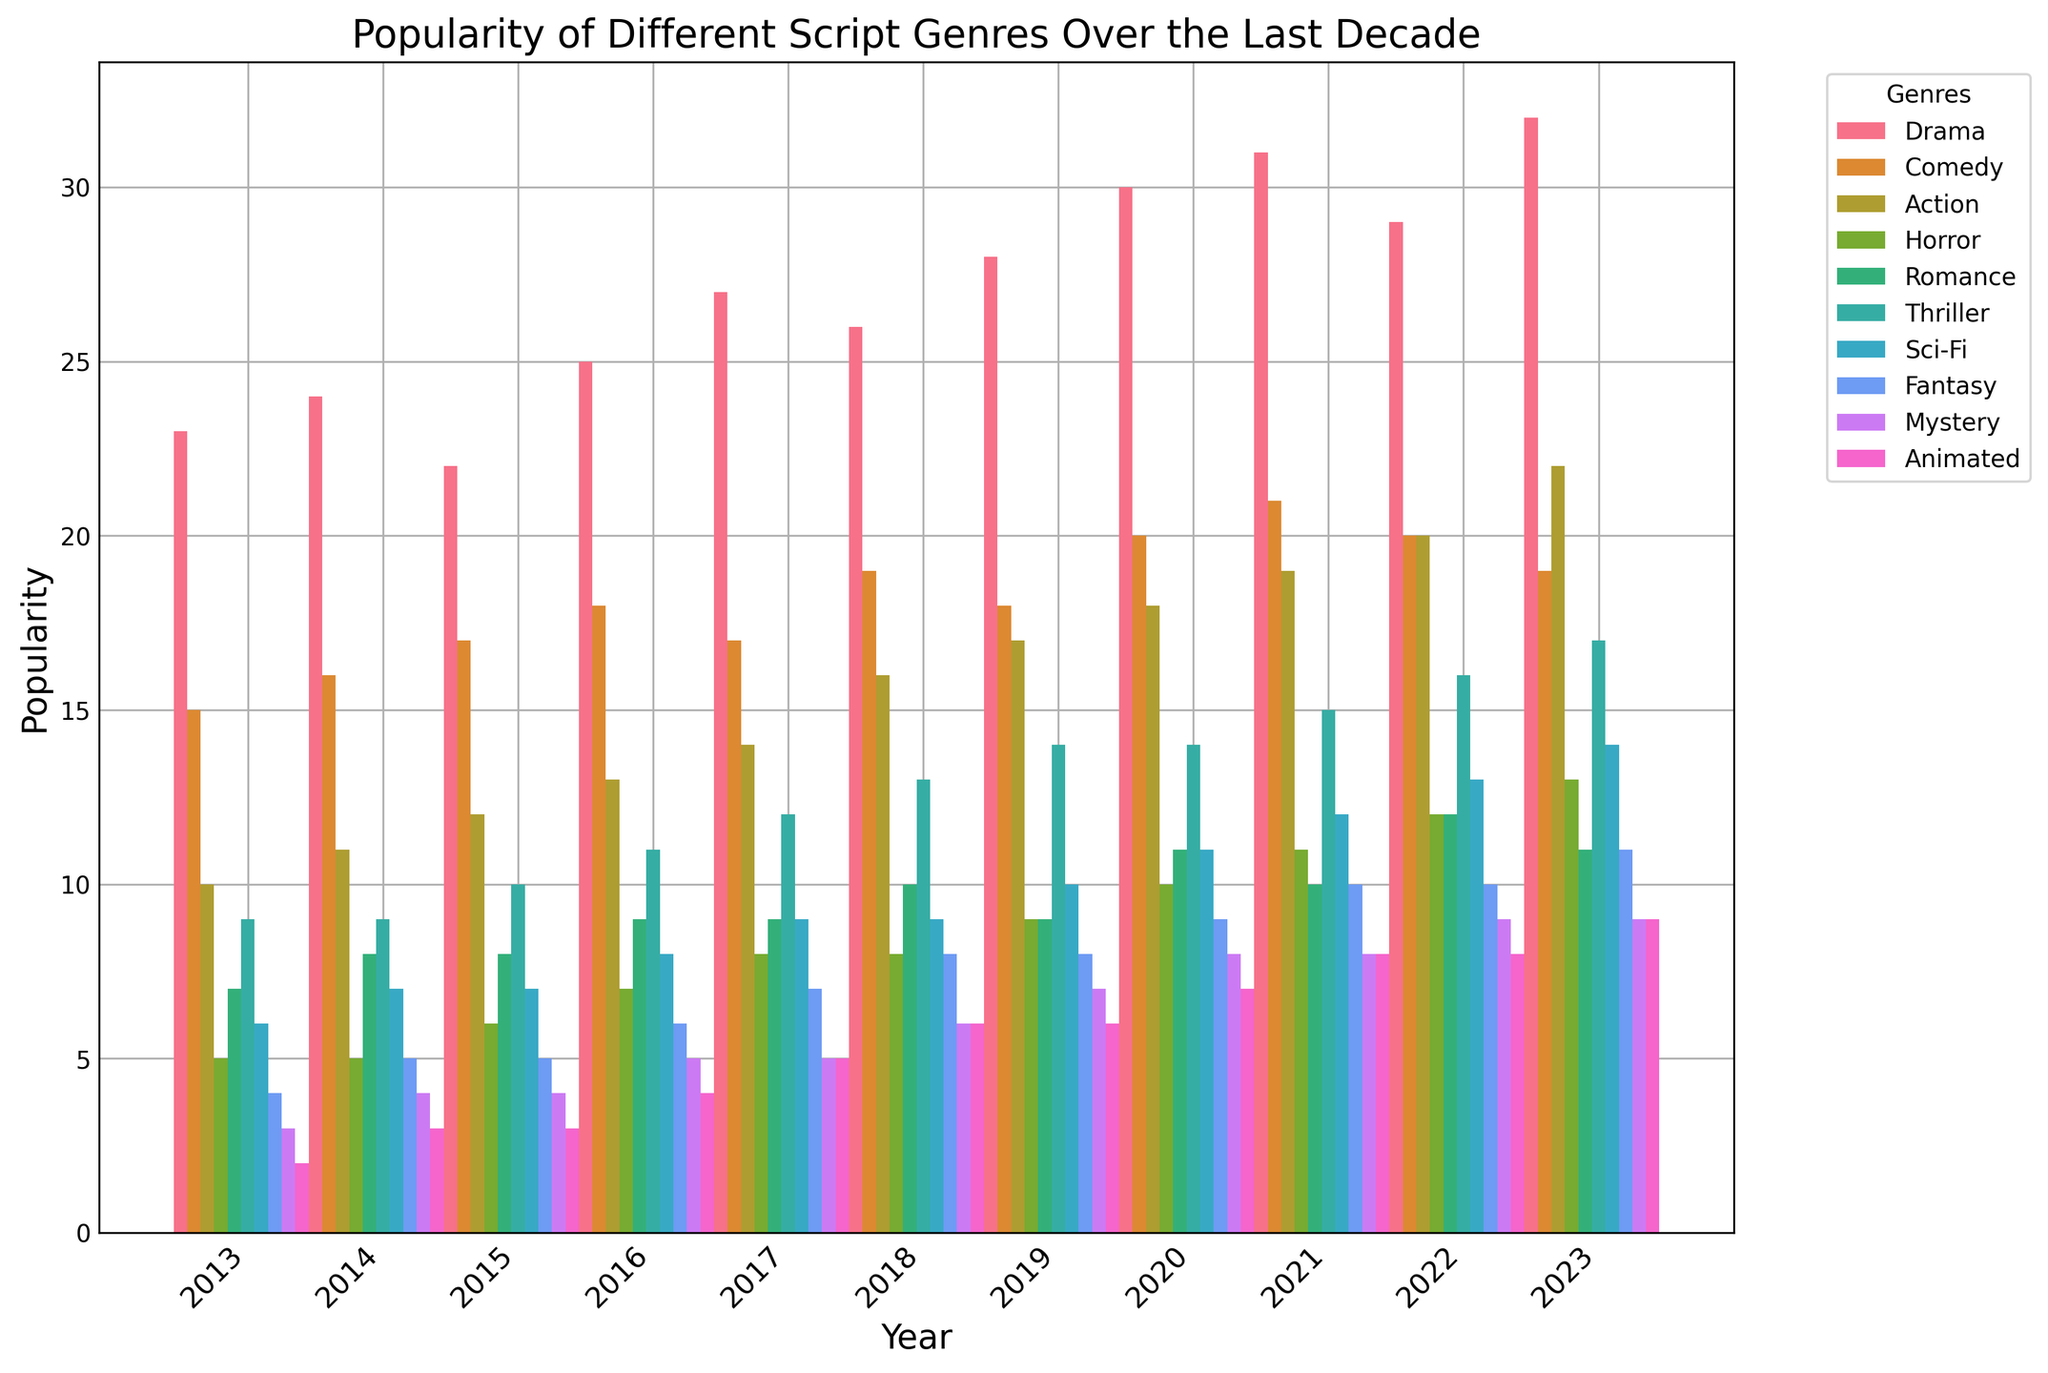Which genre saw the highest popularity in 2023? Look at the bars corresponding to the year 2023 and identify the highest one. The Drama genre has the highest bar.
Answer: Drama How did the popularity of the Comedy genre change from 2013 to 2023? Check the bars for the Comedy genre in 2013 and 2023. In 2013 it was 15, and in 2023 it was 19. The popularity increased from 15 to 19.
Answer: Increased Which genre had the least popularity in 2013, and did it remain the least popular in 2023? Identify the shortest bar in 2013, which is Animated at 2. Then compare the bars in 2023, the shortest is Mystery at 9, while Animated has 9. Thus, Animated is no longer the least popular in 2023.
Answer: No, it didn't remain the least popular Between Thriller and Sci-Fi, which genre had a higher popularity in 2022? Compare the height of the bars for Thriller and Sci-Fi in 2022. Thriller is at 16, and Sci-Fi is at 13. Thriller has a higher popularity.
Answer: Thriller Calculate the average popularity of the Fantasy genre over the last decade. Sum the values for Fantasy from 2013 to 2023 and divide by the number of years: (4+5+5+6+7+8+8+9+10+10+11)/11 = 7.18
Answer: 7.18 Which genre had the most significant increase in popularity from 2013 to 2023? Calculate the difference in popularity for each genre from 2013 to 2023. Drama: 32-23=9, Comedy: 19-15=4, Action: 22-10=12, Horror: 13-5=8, Romance: 11-7=4, Thriller: 17-9=8, Sci-Fi: 14-6=8, Fantasy: 11-4=7, Mystery: 9-3=6, Animated: 9-2=7. Action had the most significant increase.
Answer: Action What is the combined popularity of the Horror and Romance genres in 2020? Find the values for Horror and Romance in 2020 and sum them: Horror (10) + Romance (11) = 21.
Answer: 21 Which genre showed a decline in popularity in 2023 compared to 2022? Compare bars of each genre for 2022 and 2023. Comedy had 20 in 2022 and 19 in 2023, representing a decline.
Answer: Comedy Compare the popularity of the Animated genre in 2013 and 2021. Identify the heights of the bars for Animated in 2013 (2) and 2021 (8). Animated increased from 2 in 2013 to 8 in 2021.
Answer: Increased What is the visual difference in terms of bar height between the Sci-Fi genre in 2015 and 2019? Compare the bar heights of Sci-Fi in 2015 and 2019. The height in 2015 is 7, and in 2019 it is 10. The difference is 10-7=3.
Answer: 3 